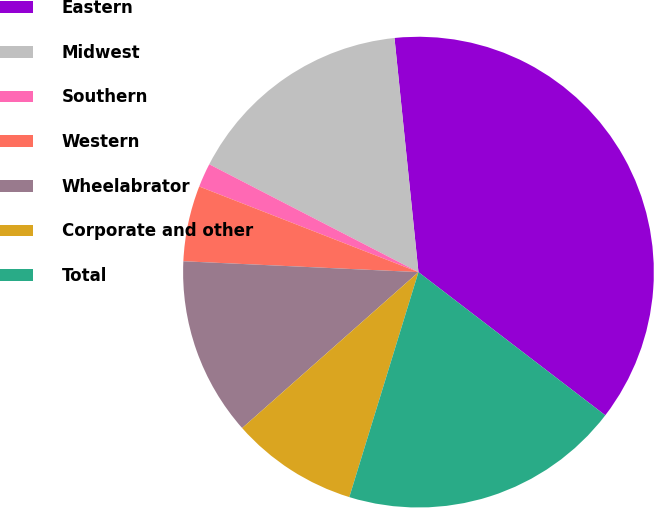Convert chart to OTSL. <chart><loc_0><loc_0><loc_500><loc_500><pie_chart><fcel>Eastern<fcel>Midwest<fcel>Southern<fcel>Western<fcel>Wheelabrator<fcel>Corporate and other<fcel>Total<nl><fcel>37.03%<fcel>15.8%<fcel>1.65%<fcel>5.19%<fcel>12.26%<fcel>8.73%<fcel>19.34%<nl></chart> 